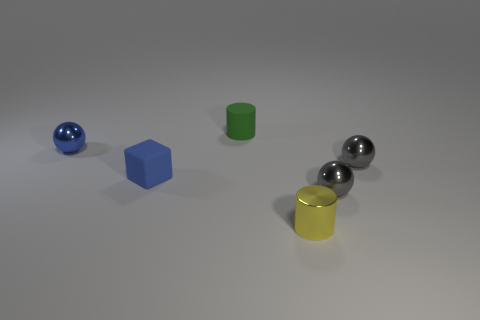The metallic thing that is the same color as the block is what shape?
Your response must be concise. Sphere. Do the small ball that is on the left side of the yellow cylinder and the matte cube have the same color?
Make the answer very short. Yes. There is a shiny sphere that is to the left of the tiny cylinder that is behind the small blue matte cube; what size is it?
Ensure brevity in your answer.  Small. There is a green thing that is the same shape as the small yellow metallic object; what is it made of?
Make the answer very short. Rubber. How many large green matte things are there?
Provide a succinct answer. 0. There is a tiny rubber object that is behind the small gray thing that is behind the rubber object that is to the left of the matte cylinder; what is its color?
Provide a short and direct response. Green. Are there fewer blue matte cubes than tiny gray matte objects?
Your answer should be very brief. No. There is another tiny thing that is the same shape as the yellow shiny object; what color is it?
Your answer should be very brief. Green. What color is the tiny cube that is made of the same material as the green thing?
Provide a short and direct response. Blue. How many blue shiny things are the same size as the block?
Your answer should be compact. 1. 